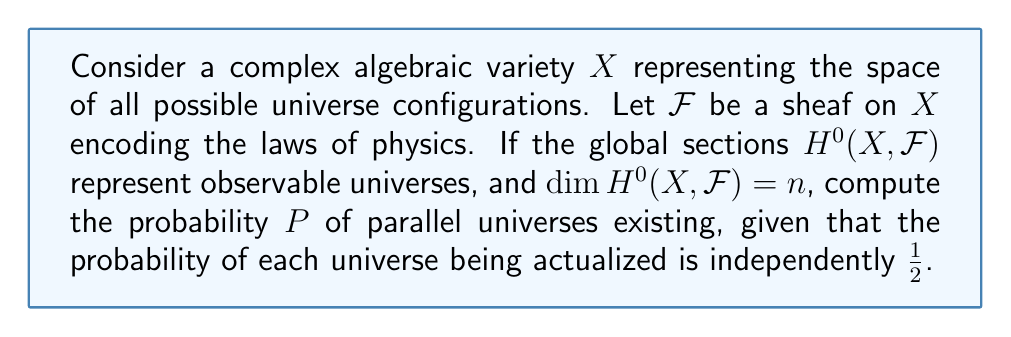Give your solution to this math problem. 1. The dimension of $H^0(X, \mathcal{F})$ being $n$ implies there are $n$ possible universes.

2. For parallel universes to exist, at least two universes must be actualized.

3. The probability of exactly $k$ universes being actualized is given by the binomial probability:

   $$P(k) = \binom{n}{k} \left(\frac{1}{2}\right)^k \left(\frac{1}{2}\right)^{n-k}$$

4. We need to sum this probability for all $k \geq 2$:

   $$P = \sum_{k=2}^n \binom{n}{k} \left(\frac{1}{2}\right)^n$$

5. This sum can be simplified using the binomial theorem:

   $$\sum_{k=0}^n \binom{n}{k} \left(\frac{1}{2}\right)^n = \left(\frac{1}{2} + \frac{1}{2}\right)^n = 1$$

6. Subtracting the cases for $k=0$ and $k=1$:

   $$P = 1 - \binom{n}{0}\left(\frac{1}{2}\right)^n - \binom{n}{1}\left(\frac{1}{2}\right)^n$$

7. Simplify:

   $$P = 1 - \left(\frac{1}{2}\right)^n - n\left(\frac{1}{2}\right)^n = 1 - (n+1)\left(\frac{1}{2}\right)^n$$

This formula gives the probability of parallel universes existing based on the algebraic geometry model.
Answer: $P = 1 - (n+1)\left(\frac{1}{2}\right)^n$ 